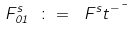Convert formula to latex. <formula><loc_0><loc_0><loc_500><loc_500>F ^ { s } _ { 0 1 } \ \colon = \ F ^ { s } t ^ { - \mu }</formula> 